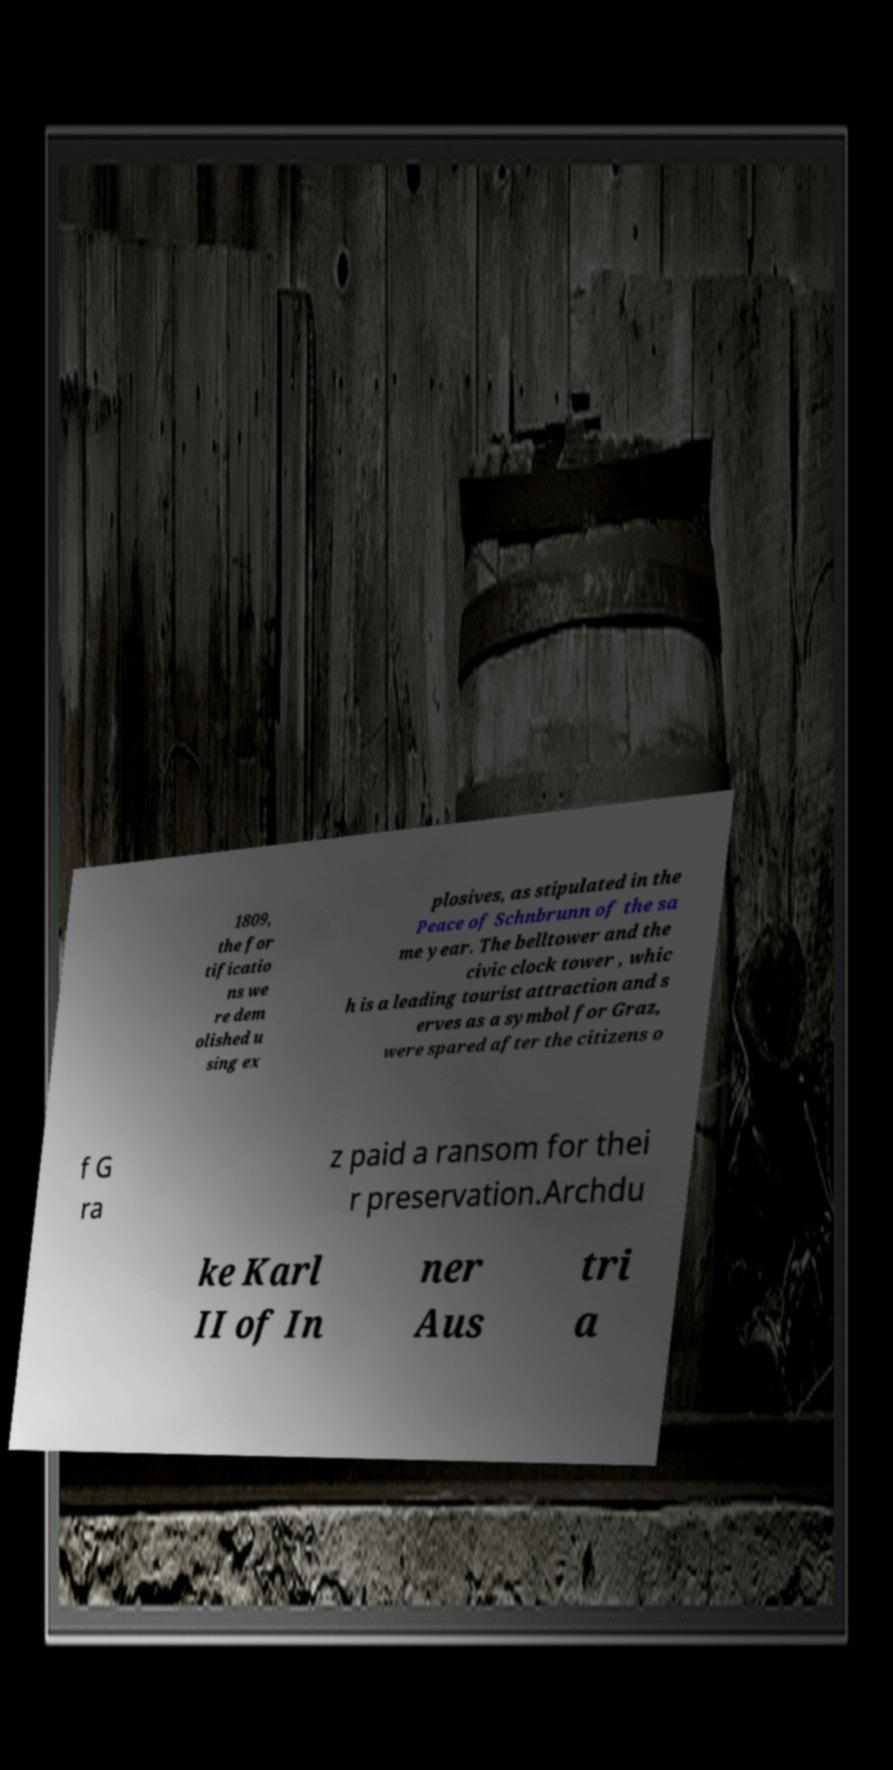There's text embedded in this image that I need extracted. Can you transcribe it verbatim? 1809, the for tificatio ns we re dem olished u sing ex plosives, as stipulated in the Peace of Schnbrunn of the sa me year. The belltower and the civic clock tower , whic h is a leading tourist attraction and s erves as a symbol for Graz, were spared after the citizens o f G ra z paid a ransom for thei r preservation.Archdu ke Karl II of In ner Aus tri a 